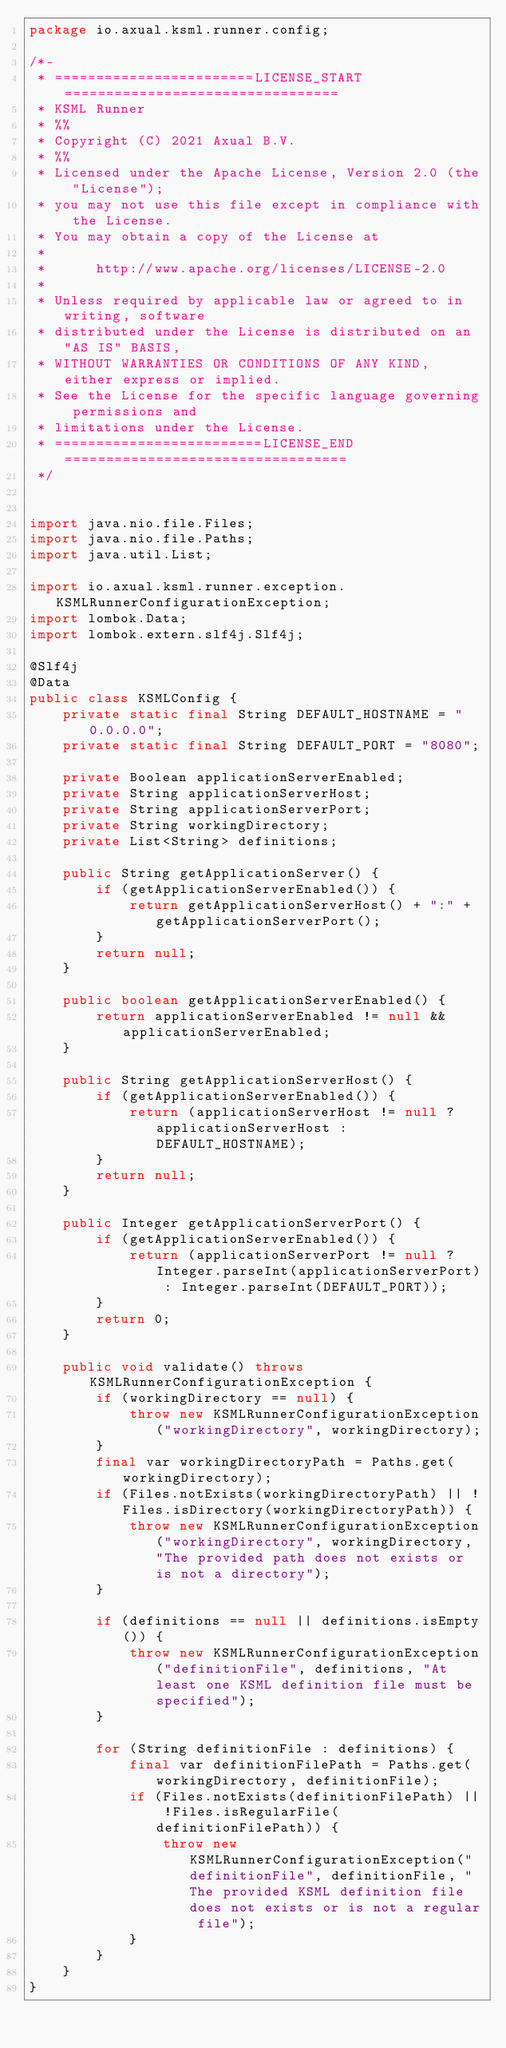<code> <loc_0><loc_0><loc_500><loc_500><_Java_>package io.axual.ksml.runner.config;

/*-
 * ========================LICENSE_START=================================
 * KSML Runner
 * %%
 * Copyright (C) 2021 Axual B.V.
 * %%
 * Licensed under the Apache License, Version 2.0 (the "License");
 * you may not use this file except in compliance with the License.
 * You may obtain a copy of the License at
 * 
 *      http://www.apache.org/licenses/LICENSE-2.0
 * 
 * Unless required by applicable law or agreed to in writing, software
 * distributed under the License is distributed on an "AS IS" BASIS,
 * WITHOUT WARRANTIES OR CONDITIONS OF ANY KIND, either express or implied.
 * See the License for the specific language governing permissions and
 * limitations under the License.
 * =========================LICENSE_END==================================
 */


import java.nio.file.Files;
import java.nio.file.Paths;
import java.util.List;

import io.axual.ksml.runner.exception.KSMLRunnerConfigurationException;
import lombok.Data;
import lombok.extern.slf4j.Slf4j;

@Slf4j
@Data
public class KSMLConfig {
    private static final String DEFAULT_HOSTNAME = "0.0.0.0";
    private static final String DEFAULT_PORT = "8080";

    private Boolean applicationServerEnabled;
    private String applicationServerHost;
    private String applicationServerPort;
    private String workingDirectory;
    private List<String> definitions;

    public String getApplicationServer() {
        if (getApplicationServerEnabled()) {
            return getApplicationServerHost() + ":" + getApplicationServerPort();
        }
        return null;
    }

    public boolean getApplicationServerEnabled() {
        return applicationServerEnabled != null && applicationServerEnabled;
    }

    public String getApplicationServerHost() {
        if (getApplicationServerEnabled()) {
            return (applicationServerHost != null ? applicationServerHost : DEFAULT_HOSTNAME);
        }
        return null;
    }

    public Integer getApplicationServerPort() {
        if (getApplicationServerEnabled()) {
            return (applicationServerPort != null ? Integer.parseInt(applicationServerPort) : Integer.parseInt(DEFAULT_PORT));
        }
        return 0;
    }

    public void validate() throws KSMLRunnerConfigurationException {
        if (workingDirectory == null) {
            throw new KSMLRunnerConfigurationException("workingDirectory", workingDirectory);
        }
        final var workingDirectoryPath = Paths.get(workingDirectory);
        if (Files.notExists(workingDirectoryPath) || !Files.isDirectory(workingDirectoryPath)) {
            throw new KSMLRunnerConfigurationException("workingDirectory", workingDirectory, "The provided path does not exists or is not a directory");
        }

        if (definitions == null || definitions.isEmpty()) {
            throw new KSMLRunnerConfigurationException("definitionFile", definitions, "At least one KSML definition file must be specified");
        }

        for (String definitionFile : definitions) {
            final var definitionFilePath = Paths.get(workingDirectory, definitionFile);
            if (Files.notExists(definitionFilePath) || !Files.isRegularFile(definitionFilePath)) {
                throw new KSMLRunnerConfigurationException("definitionFile", definitionFile, "The provided KSML definition file does not exists or is not a regular file");
            }
        }
    }
}
</code> 